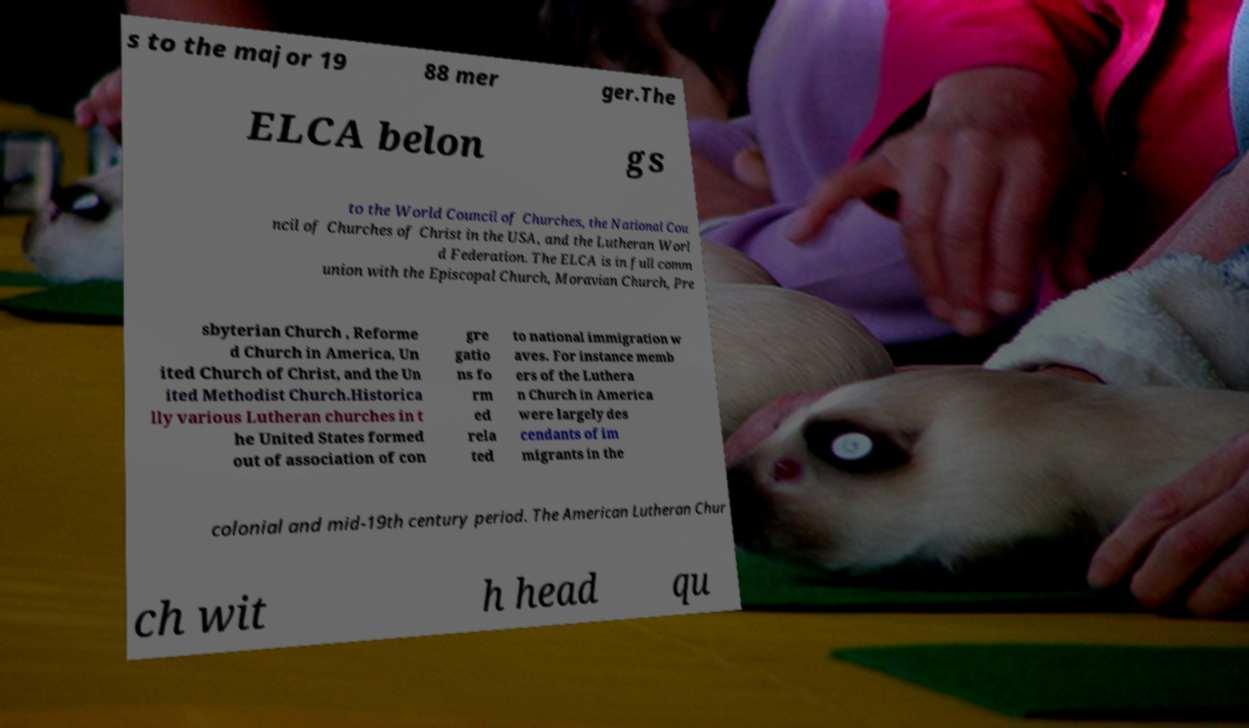Could you extract and type out the text from this image? s to the major 19 88 mer ger.The ELCA belon gs to the World Council of Churches, the National Cou ncil of Churches of Christ in the USA, and the Lutheran Worl d Federation. The ELCA is in full comm union with the Episcopal Church, Moravian Church, Pre sbyterian Church , Reforme d Church in America, Un ited Church of Christ, and the Un ited Methodist Church.Historica lly various Lutheran churches in t he United States formed out of association of con gre gatio ns fo rm ed rela ted to national immigration w aves. For instance memb ers of the Luthera n Church in America were largely des cendants of im migrants in the colonial and mid-19th century period. The American Lutheran Chur ch wit h head qu 